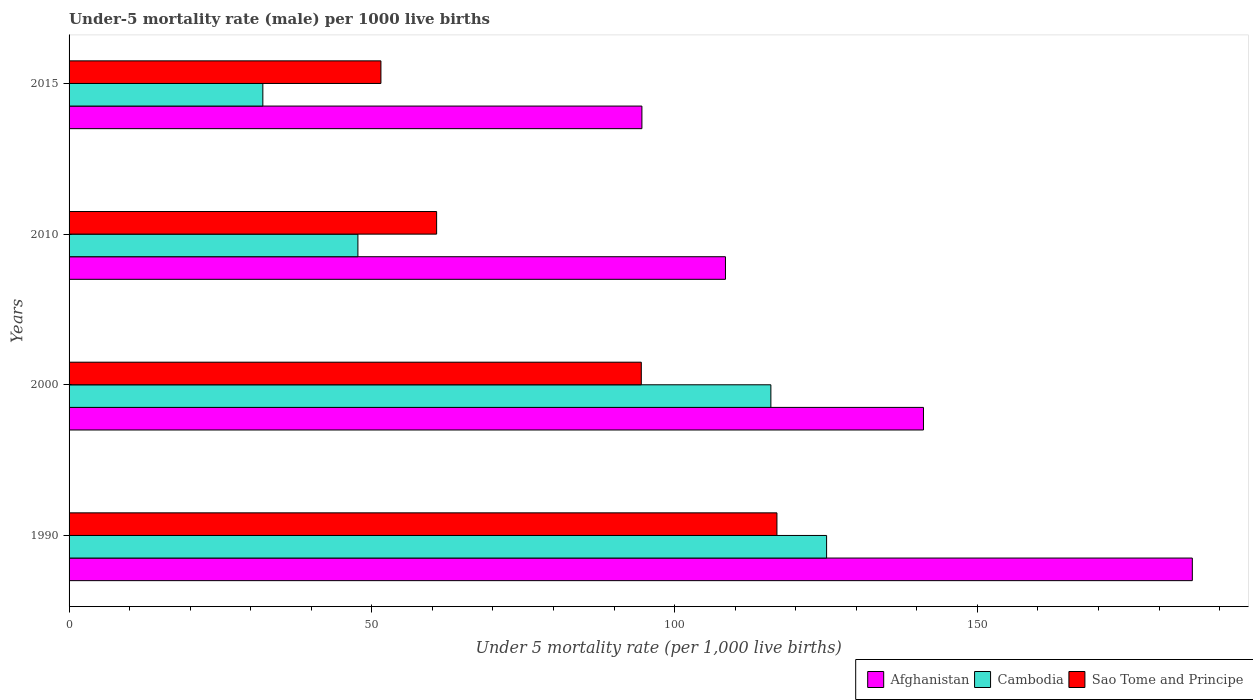How many bars are there on the 3rd tick from the top?
Your answer should be very brief. 3. What is the label of the 3rd group of bars from the top?
Ensure brevity in your answer.  2000. In how many cases, is the number of bars for a given year not equal to the number of legend labels?
Give a very brief answer. 0. What is the under-five mortality rate in Cambodia in 2010?
Your response must be concise. 47.7. Across all years, what is the maximum under-five mortality rate in Cambodia?
Offer a very short reply. 125.1. Across all years, what is the minimum under-five mortality rate in Afghanistan?
Provide a short and direct response. 94.6. In which year was the under-five mortality rate in Sao Tome and Principe maximum?
Your answer should be very brief. 1990. In which year was the under-five mortality rate in Afghanistan minimum?
Ensure brevity in your answer.  2015. What is the total under-five mortality rate in Afghanistan in the graph?
Make the answer very short. 529.6. What is the difference between the under-five mortality rate in Sao Tome and Principe in 2010 and that in 2015?
Provide a short and direct response. 9.2. What is the difference between the under-five mortality rate in Cambodia in 1990 and the under-five mortality rate in Afghanistan in 2000?
Provide a short and direct response. -16. What is the average under-five mortality rate in Cambodia per year?
Offer a very short reply. 80.17. In the year 2000, what is the difference between the under-five mortality rate in Sao Tome and Principe and under-five mortality rate in Afghanistan?
Keep it short and to the point. -46.6. What is the ratio of the under-five mortality rate in Sao Tome and Principe in 2000 to that in 2015?
Provide a short and direct response. 1.83. Is the under-five mortality rate in Sao Tome and Principe in 2000 less than that in 2015?
Your answer should be compact. No. What is the difference between the highest and the second highest under-five mortality rate in Sao Tome and Principe?
Your response must be concise. 22.4. What is the difference between the highest and the lowest under-five mortality rate in Sao Tome and Principe?
Offer a very short reply. 65.4. What does the 3rd bar from the top in 1990 represents?
Provide a short and direct response. Afghanistan. What does the 3rd bar from the bottom in 2015 represents?
Make the answer very short. Sao Tome and Principe. Is it the case that in every year, the sum of the under-five mortality rate in Cambodia and under-five mortality rate in Sao Tome and Principe is greater than the under-five mortality rate in Afghanistan?
Your response must be concise. No. How many years are there in the graph?
Ensure brevity in your answer.  4. Does the graph contain any zero values?
Make the answer very short. No. Where does the legend appear in the graph?
Your answer should be very brief. Bottom right. How many legend labels are there?
Offer a terse response. 3. How are the legend labels stacked?
Offer a very short reply. Horizontal. What is the title of the graph?
Provide a succinct answer. Under-5 mortality rate (male) per 1000 live births. Does "Denmark" appear as one of the legend labels in the graph?
Ensure brevity in your answer.  No. What is the label or title of the X-axis?
Give a very brief answer. Under 5 mortality rate (per 1,0 live births). What is the Under 5 mortality rate (per 1,000 live births) in Afghanistan in 1990?
Offer a very short reply. 185.5. What is the Under 5 mortality rate (per 1,000 live births) of Cambodia in 1990?
Offer a terse response. 125.1. What is the Under 5 mortality rate (per 1,000 live births) of Sao Tome and Principe in 1990?
Keep it short and to the point. 116.9. What is the Under 5 mortality rate (per 1,000 live births) of Afghanistan in 2000?
Ensure brevity in your answer.  141.1. What is the Under 5 mortality rate (per 1,000 live births) of Cambodia in 2000?
Offer a very short reply. 115.9. What is the Under 5 mortality rate (per 1,000 live births) of Sao Tome and Principe in 2000?
Your answer should be very brief. 94.5. What is the Under 5 mortality rate (per 1,000 live births) of Afghanistan in 2010?
Offer a very short reply. 108.4. What is the Under 5 mortality rate (per 1,000 live births) in Cambodia in 2010?
Your answer should be very brief. 47.7. What is the Under 5 mortality rate (per 1,000 live births) of Sao Tome and Principe in 2010?
Provide a succinct answer. 60.7. What is the Under 5 mortality rate (per 1,000 live births) of Afghanistan in 2015?
Your answer should be compact. 94.6. What is the Under 5 mortality rate (per 1,000 live births) in Sao Tome and Principe in 2015?
Offer a very short reply. 51.5. Across all years, what is the maximum Under 5 mortality rate (per 1,000 live births) of Afghanistan?
Offer a very short reply. 185.5. Across all years, what is the maximum Under 5 mortality rate (per 1,000 live births) in Cambodia?
Keep it short and to the point. 125.1. Across all years, what is the maximum Under 5 mortality rate (per 1,000 live births) in Sao Tome and Principe?
Your response must be concise. 116.9. Across all years, what is the minimum Under 5 mortality rate (per 1,000 live births) in Afghanistan?
Keep it short and to the point. 94.6. Across all years, what is the minimum Under 5 mortality rate (per 1,000 live births) in Cambodia?
Offer a terse response. 32. Across all years, what is the minimum Under 5 mortality rate (per 1,000 live births) of Sao Tome and Principe?
Provide a short and direct response. 51.5. What is the total Under 5 mortality rate (per 1,000 live births) in Afghanistan in the graph?
Provide a short and direct response. 529.6. What is the total Under 5 mortality rate (per 1,000 live births) in Cambodia in the graph?
Ensure brevity in your answer.  320.7. What is the total Under 5 mortality rate (per 1,000 live births) of Sao Tome and Principe in the graph?
Your answer should be very brief. 323.6. What is the difference between the Under 5 mortality rate (per 1,000 live births) in Afghanistan in 1990 and that in 2000?
Your answer should be very brief. 44.4. What is the difference between the Under 5 mortality rate (per 1,000 live births) of Cambodia in 1990 and that in 2000?
Give a very brief answer. 9.2. What is the difference between the Under 5 mortality rate (per 1,000 live births) of Sao Tome and Principe in 1990 and that in 2000?
Offer a terse response. 22.4. What is the difference between the Under 5 mortality rate (per 1,000 live births) in Afghanistan in 1990 and that in 2010?
Your answer should be very brief. 77.1. What is the difference between the Under 5 mortality rate (per 1,000 live births) of Cambodia in 1990 and that in 2010?
Make the answer very short. 77.4. What is the difference between the Under 5 mortality rate (per 1,000 live births) of Sao Tome and Principe in 1990 and that in 2010?
Your response must be concise. 56.2. What is the difference between the Under 5 mortality rate (per 1,000 live births) in Afghanistan in 1990 and that in 2015?
Your answer should be compact. 90.9. What is the difference between the Under 5 mortality rate (per 1,000 live births) in Cambodia in 1990 and that in 2015?
Your answer should be very brief. 93.1. What is the difference between the Under 5 mortality rate (per 1,000 live births) of Sao Tome and Principe in 1990 and that in 2015?
Your answer should be very brief. 65.4. What is the difference between the Under 5 mortality rate (per 1,000 live births) in Afghanistan in 2000 and that in 2010?
Ensure brevity in your answer.  32.7. What is the difference between the Under 5 mortality rate (per 1,000 live births) of Cambodia in 2000 and that in 2010?
Offer a terse response. 68.2. What is the difference between the Under 5 mortality rate (per 1,000 live births) of Sao Tome and Principe in 2000 and that in 2010?
Provide a succinct answer. 33.8. What is the difference between the Under 5 mortality rate (per 1,000 live births) in Afghanistan in 2000 and that in 2015?
Your answer should be very brief. 46.5. What is the difference between the Under 5 mortality rate (per 1,000 live births) in Cambodia in 2000 and that in 2015?
Give a very brief answer. 83.9. What is the difference between the Under 5 mortality rate (per 1,000 live births) in Afghanistan in 2010 and that in 2015?
Provide a succinct answer. 13.8. What is the difference between the Under 5 mortality rate (per 1,000 live births) in Cambodia in 2010 and that in 2015?
Offer a very short reply. 15.7. What is the difference between the Under 5 mortality rate (per 1,000 live births) of Afghanistan in 1990 and the Under 5 mortality rate (per 1,000 live births) of Cambodia in 2000?
Your answer should be compact. 69.6. What is the difference between the Under 5 mortality rate (per 1,000 live births) of Afghanistan in 1990 and the Under 5 mortality rate (per 1,000 live births) of Sao Tome and Principe in 2000?
Your response must be concise. 91. What is the difference between the Under 5 mortality rate (per 1,000 live births) in Cambodia in 1990 and the Under 5 mortality rate (per 1,000 live births) in Sao Tome and Principe in 2000?
Your response must be concise. 30.6. What is the difference between the Under 5 mortality rate (per 1,000 live births) in Afghanistan in 1990 and the Under 5 mortality rate (per 1,000 live births) in Cambodia in 2010?
Keep it short and to the point. 137.8. What is the difference between the Under 5 mortality rate (per 1,000 live births) of Afghanistan in 1990 and the Under 5 mortality rate (per 1,000 live births) of Sao Tome and Principe in 2010?
Offer a very short reply. 124.8. What is the difference between the Under 5 mortality rate (per 1,000 live births) in Cambodia in 1990 and the Under 5 mortality rate (per 1,000 live births) in Sao Tome and Principe in 2010?
Give a very brief answer. 64.4. What is the difference between the Under 5 mortality rate (per 1,000 live births) in Afghanistan in 1990 and the Under 5 mortality rate (per 1,000 live births) in Cambodia in 2015?
Provide a short and direct response. 153.5. What is the difference between the Under 5 mortality rate (per 1,000 live births) of Afghanistan in 1990 and the Under 5 mortality rate (per 1,000 live births) of Sao Tome and Principe in 2015?
Offer a terse response. 134. What is the difference between the Under 5 mortality rate (per 1,000 live births) of Cambodia in 1990 and the Under 5 mortality rate (per 1,000 live births) of Sao Tome and Principe in 2015?
Offer a very short reply. 73.6. What is the difference between the Under 5 mortality rate (per 1,000 live births) in Afghanistan in 2000 and the Under 5 mortality rate (per 1,000 live births) in Cambodia in 2010?
Your answer should be very brief. 93.4. What is the difference between the Under 5 mortality rate (per 1,000 live births) in Afghanistan in 2000 and the Under 5 mortality rate (per 1,000 live births) in Sao Tome and Principe in 2010?
Ensure brevity in your answer.  80.4. What is the difference between the Under 5 mortality rate (per 1,000 live births) of Cambodia in 2000 and the Under 5 mortality rate (per 1,000 live births) of Sao Tome and Principe in 2010?
Your answer should be very brief. 55.2. What is the difference between the Under 5 mortality rate (per 1,000 live births) of Afghanistan in 2000 and the Under 5 mortality rate (per 1,000 live births) of Cambodia in 2015?
Your response must be concise. 109.1. What is the difference between the Under 5 mortality rate (per 1,000 live births) in Afghanistan in 2000 and the Under 5 mortality rate (per 1,000 live births) in Sao Tome and Principe in 2015?
Give a very brief answer. 89.6. What is the difference between the Under 5 mortality rate (per 1,000 live births) in Cambodia in 2000 and the Under 5 mortality rate (per 1,000 live births) in Sao Tome and Principe in 2015?
Offer a terse response. 64.4. What is the difference between the Under 5 mortality rate (per 1,000 live births) of Afghanistan in 2010 and the Under 5 mortality rate (per 1,000 live births) of Cambodia in 2015?
Your answer should be very brief. 76.4. What is the difference between the Under 5 mortality rate (per 1,000 live births) in Afghanistan in 2010 and the Under 5 mortality rate (per 1,000 live births) in Sao Tome and Principe in 2015?
Make the answer very short. 56.9. What is the average Under 5 mortality rate (per 1,000 live births) of Afghanistan per year?
Offer a very short reply. 132.4. What is the average Under 5 mortality rate (per 1,000 live births) in Cambodia per year?
Keep it short and to the point. 80.17. What is the average Under 5 mortality rate (per 1,000 live births) of Sao Tome and Principe per year?
Your answer should be compact. 80.9. In the year 1990, what is the difference between the Under 5 mortality rate (per 1,000 live births) of Afghanistan and Under 5 mortality rate (per 1,000 live births) of Cambodia?
Your response must be concise. 60.4. In the year 1990, what is the difference between the Under 5 mortality rate (per 1,000 live births) in Afghanistan and Under 5 mortality rate (per 1,000 live births) in Sao Tome and Principe?
Make the answer very short. 68.6. In the year 1990, what is the difference between the Under 5 mortality rate (per 1,000 live births) in Cambodia and Under 5 mortality rate (per 1,000 live births) in Sao Tome and Principe?
Your response must be concise. 8.2. In the year 2000, what is the difference between the Under 5 mortality rate (per 1,000 live births) in Afghanistan and Under 5 mortality rate (per 1,000 live births) in Cambodia?
Your response must be concise. 25.2. In the year 2000, what is the difference between the Under 5 mortality rate (per 1,000 live births) in Afghanistan and Under 5 mortality rate (per 1,000 live births) in Sao Tome and Principe?
Offer a very short reply. 46.6. In the year 2000, what is the difference between the Under 5 mortality rate (per 1,000 live births) in Cambodia and Under 5 mortality rate (per 1,000 live births) in Sao Tome and Principe?
Provide a short and direct response. 21.4. In the year 2010, what is the difference between the Under 5 mortality rate (per 1,000 live births) of Afghanistan and Under 5 mortality rate (per 1,000 live births) of Cambodia?
Offer a terse response. 60.7. In the year 2010, what is the difference between the Under 5 mortality rate (per 1,000 live births) in Afghanistan and Under 5 mortality rate (per 1,000 live births) in Sao Tome and Principe?
Make the answer very short. 47.7. In the year 2010, what is the difference between the Under 5 mortality rate (per 1,000 live births) of Cambodia and Under 5 mortality rate (per 1,000 live births) of Sao Tome and Principe?
Give a very brief answer. -13. In the year 2015, what is the difference between the Under 5 mortality rate (per 1,000 live births) of Afghanistan and Under 5 mortality rate (per 1,000 live births) of Cambodia?
Provide a short and direct response. 62.6. In the year 2015, what is the difference between the Under 5 mortality rate (per 1,000 live births) of Afghanistan and Under 5 mortality rate (per 1,000 live births) of Sao Tome and Principe?
Offer a terse response. 43.1. In the year 2015, what is the difference between the Under 5 mortality rate (per 1,000 live births) of Cambodia and Under 5 mortality rate (per 1,000 live births) of Sao Tome and Principe?
Offer a terse response. -19.5. What is the ratio of the Under 5 mortality rate (per 1,000 live births) of Afghanistan in 1990 to that in 2000?
Keep it short and to the point. 1.31. What is the ratio of the Under 5 mortality rate (per 1,000 live births) of Cambodia in 1990 to that in 2000?
Offer a terse response. 1.08. What is the ratio of the Under 5 mortality rate (per 1,000 live births) in Sao Tome and Principe in 1990 to that in 2000?
Offer a very short reply. 1.24. What is the ratio of the Under 5 mortality rate (per 1,000 live births) in Afghanistan in 1990 to that in 2010?
Offer a very short reply. 1.71. What is the ratio of the Under 5 mortality rate (per 1,000 live births) in Cambodia in 1990 to that in 2010?
Your answer should be very brief. 2.62. What is the ratio of the Under 5 mortality rate (per 1,000 live births) of Sao Tome and Principe in 1990 to that in 2010?
Keep it short and to the point. 1.93. What is the ratio of the Under 5 mortality rate (per 1,000 live births) in Afghanistan in 1990 to that in 2015?
Make the answer very short. 1.96. What is the ratio of the Under 5 mortality rate (per 1,000 live births) of Cambodia in 1990 to that in 2015?
Your answer should be very brief. 3.91. What is the ratio of the Under 5 mortality rate (per 1,000 live births) in Sao Tome and Principe in 1990 to that in 2015?
Make the answer very short. 2.27. What is the ratio of the Under 5 mortality rate (per 1,000 live births) of Afghanistan in 2000 to that in 2010?
Provide a succinct answer. 1.3. What is the ratio of the Under 5 mortality rate (per 1,000 live births) in Cambodia in 2000 to that in 2010?
Your answer should be compact. 2.43. What is the ratio of the Under 5 mortality rate (per 1,000 live births) of Sao Tome and Principe in 2000 to that in 2010?
Ensure brevity in your answer.  1.56. What is the ratio of the Under 5 mortality rate (per 1,000 live births) in Afghanistan in 2000 to that in 2015?
Offer a terse response. 1.49. What is the ratio of the Under 5 mortality rate (per 1,000 live births) in Cambodia in 2000 to that in 2015?
Give a very brief answer. 3.62. What is the ratio of the Under 5 mortality rate (per 1,000 live births) in Sao Tome and Principe in 2000 to that in 2015?
Provide a succinct answer. 1.83. What is the ratio of the Under 5 mortality rate (per 1,000 live births) in Afghanistan in 2010 to that in 2015?
Provide a short and direct response. 1.15. What is the ratio of the Under 5 mortality rate (per 1,000 live births) of Cambodia in 2010 to that in 2015?
Your answer should be compact. 1.49. What is the ratio of the Under 5 mortality rate (per 1,000 live births) of Sao Tome and Principe in 2010 to that in 2015?
Ensure brevity in your answer.  1.18. What is the difference between the highest and the second highest Under 5 mortality rate (per 1,000 live births) of Afghanistan?
Your answer should be very brief. 44.4. What is the difference between the highest and the second highest Under 5 mortality rate (per 1,000 live births) in Sao Tome and Principe?
Offer a terse response. 22.4. What is the difference between the highest and the lowest Under 5 mortality rate (per 1,000 live births) of Afghanistan?
Your answer should be compact. 90.9. What is the difference between the highest and the lowest Under 5 mortality rate (per 1,000 live births) in Cambodia?
Your answer should be compact. 93.1. What is the difference between the highest and the lowest Under 5 mortality rate (per 1,000 live births) of Sao Tome and Principe?
Offer a very short reply. 65.4. 